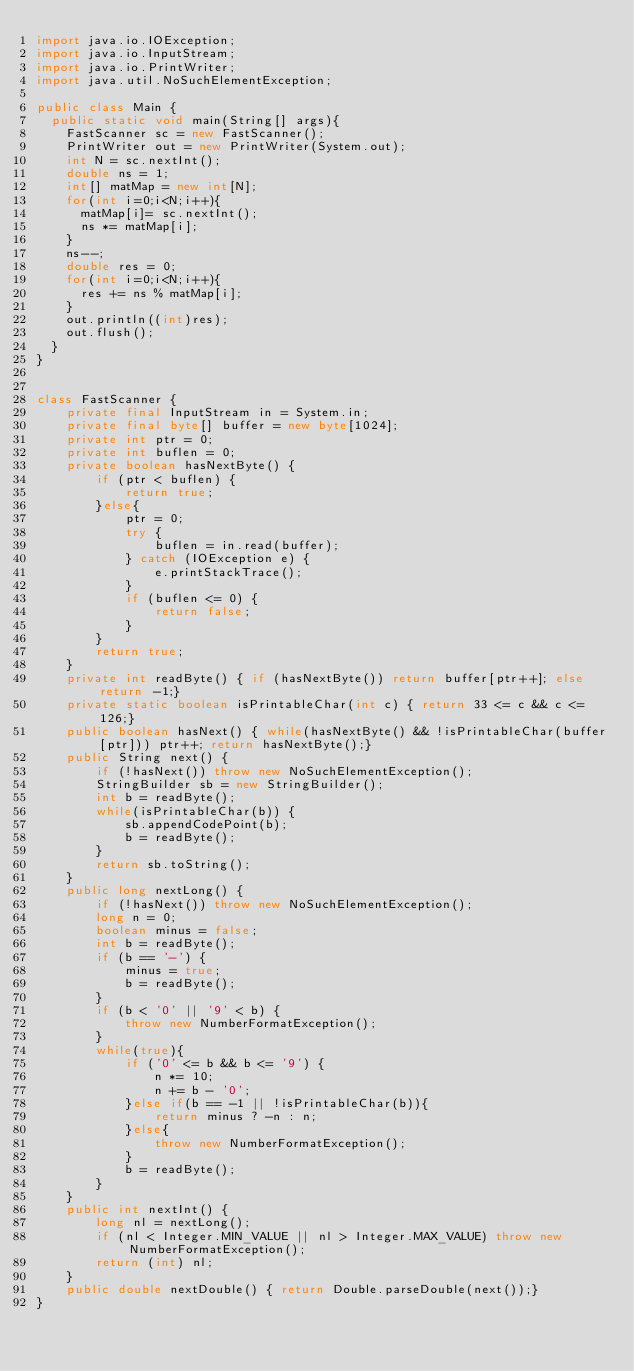<code> <loc_0><loc_0><loc_500><loc_500><_Java_>import java.io.IOException;
import java.io.InputStream;
import java.io.PrintWriter;
import java.util.NoSuchElementException;

public class Main {
	public static void main(String[] args){
		FastScanner sc = new FastScanner();
		PrintWriter out = new PrintWriter(System.out);
		int N = sc.nextInt();
		double ns = 1;
		int[] matMap = new int[N];
		for(int i=0;i<N;i++){
			matMap[i]= sc.nextInt();
			ns *= matMap[i];
		}
		ns--;
		double res = 0;
		for(int i=0;i<N;i++){
			res += ns % matMap[i];
		}
		out.println((int)res);
		out.flush();
	}
}


class FastScanner {
    private final InputStream in = System.in;
    private final byte[] buffer = new byte[1024];
    private int ptr = 0;
    private int buflen = 0;
    private boolean hasNextByte() {
        if (ptr < buflen) {
            return true;
        }else{
            ptr = 0;
            try {
                buflen = in.read(buffer);
            } catch (IOException e) {
                e.printStackTrace();
            }
            if (buflen <= 0) {
                return false;
            }
        }
        return true;
    }
    private int readByte() { if (hasNextByte()) return buffer[ptr++]; else return -1;}
    private static boolean isPrintableChar(int c) { return 33 <= c && c <= 126;}
    public boolean hasNext() { while(hasNextByte() && !isPrintableChar(buffer[ptr])) ptr++; return hasNextByte();}
    public String next() {
        if (!hasNext()) throw new NoSuchElementException();
        StringBuilder sb = new StringBuilder();
        int b = readByte();
        while(isPrintableChar(b)) {
            sb.appendCodePoint(b);
            b = readByte();
        }
        return sb.toString();
    }
    public long nextLong() {
        if (!hasNext()) throw new NoSuchElementException();
        long n = 0;
        boolean minus = false;
        int b = readByte();
        if (b == '-') {
            minus = true;
            b = readByte();
        }
        if (b < '0' || '9' < b) {
            throw new NumberFormatException();
        }
        while(true){
            if ('0' <= b && b <= '9') {
                n *= 10;
                n += b - '0';
            }else if(b == -1 || !isPrintableChar(b)){
                return minus ? -n : n;
            }else{
                throw new NumberFormatException();
            }
            b = readByte();
        }
    }
    public int nextInt() {
        long nl = nextLong();
        if (nl < Integer.MIN_VALUE || nl > Integer.MAX_VALUE) throw new NumberFormatException();
        return (int) nl;
    }
    public double nextDouble() { return Double.parseDouble(next());}
}</code> 